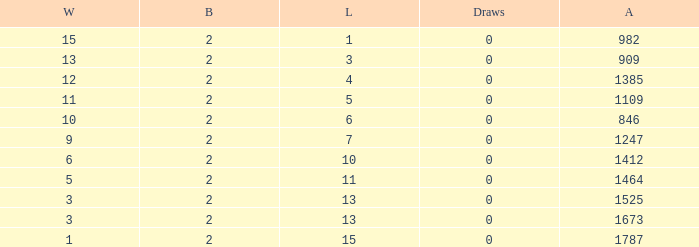Give me the full table as a dictionary. {'header': ['W', 'B', 'L', 'Draws', 'A'], 'rows': [['15', '2', '1', '0', '982'], ['13', '2', '3', '0', '909'], ['12', '2', '4', '0', '1385'], ['11', '2', '5', '0', '1109'], ['10', '2', '6', '0', '846'], ['9', '2', '7', '0', '1247'], ['6', '2', '10', '0', '1412'], ['5', '2', '11', '0', '1464'], ['3', '2', '13', '0', '1525'], ['3', '2', '13', '0', '1673'], ['1', '2', '15', '0', '1787']]} What is the highest number listed under against when there were less than 3 wins and less than 15 losses? None. 